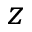Convert formula to latex. <formula><loc_0><loc_0><loc_500><loc_500>z</formula> 